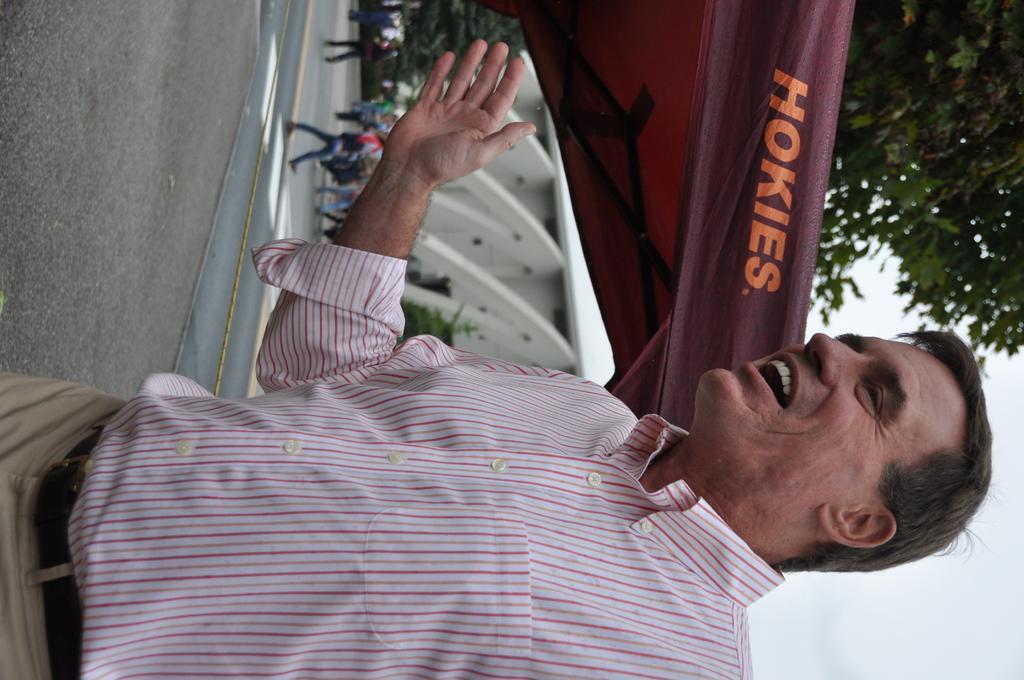Please provide a concise description of this image. In this image we can see a man. In the background few persons are walking on the road, trees, building, tent and clouds in the sky. 